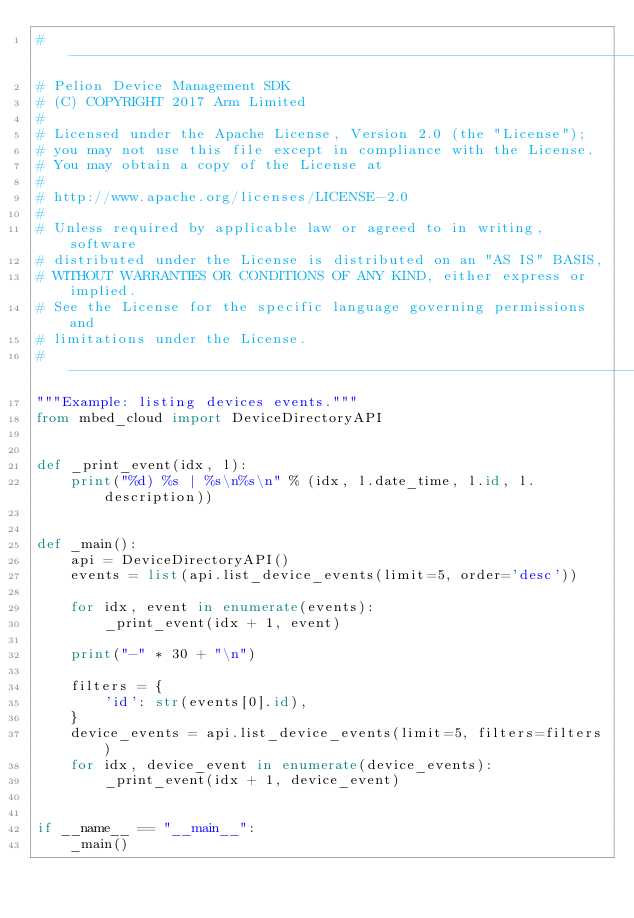<code> <loc_0><loc_0><loc_500><loc_500><_Python_># ---------------------------------------------------------------------------
# Pelion Device Management SDK
# (C) COPYRIGHT 2017 Arm Limited
#
# Licensed under the Apache License, Version 2.0 (the "License");
# you may not use this file except in compliance with the License.
# You may obtain a copy of the License at
#
# http://www.apache.org/licenses/LICENSE-2.0
#
# Unless required by applicable law or agreed to in writing, software
# distributed under the License is distributed on an "AS IS" BASIS,
# WITHOUT WARRANTIES OR CONDITIONS OF ANY KIND, either express or implied.
# See the License for the specific language governing permissions and
# limitations under the License.
# --------------------------------------------------------------------------
"""Example: listing devices events."""
from mbed_cloud import DeviceDirectoryAPI


def _print_event(idx, l):
    print("%d) %s | %s\n%s\n" % (idx, l.date_time, l.id, l.description))


def _main():
    api = DeviceDirectoryAPI()
    events = list(api.list_device_events(limit=5, order='desc'))

    for idx, event in enumerate(events):
        _print_event(idx + 1, event)

    print("-" * 30 + "\n")

    filters = {
        'id': str(events[0].id),
    }
    device_events = api.list_device_events(limit=5, filters=filters)
    for idx, device_event in enumerate(device_events):
        _print_event(idx + 1, device_event)


if __name__ == "__main__":
    _main()
</code> 